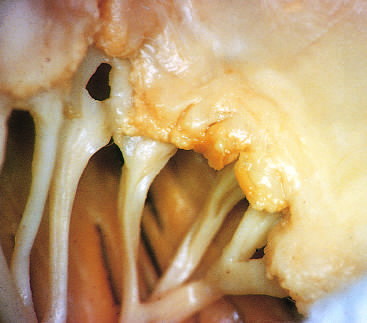what have caused fibrous thickening and fusion of the chordae tendineae?
Answer the question using a single word or phrase. Previous episodes of rheumatic valvulitis 